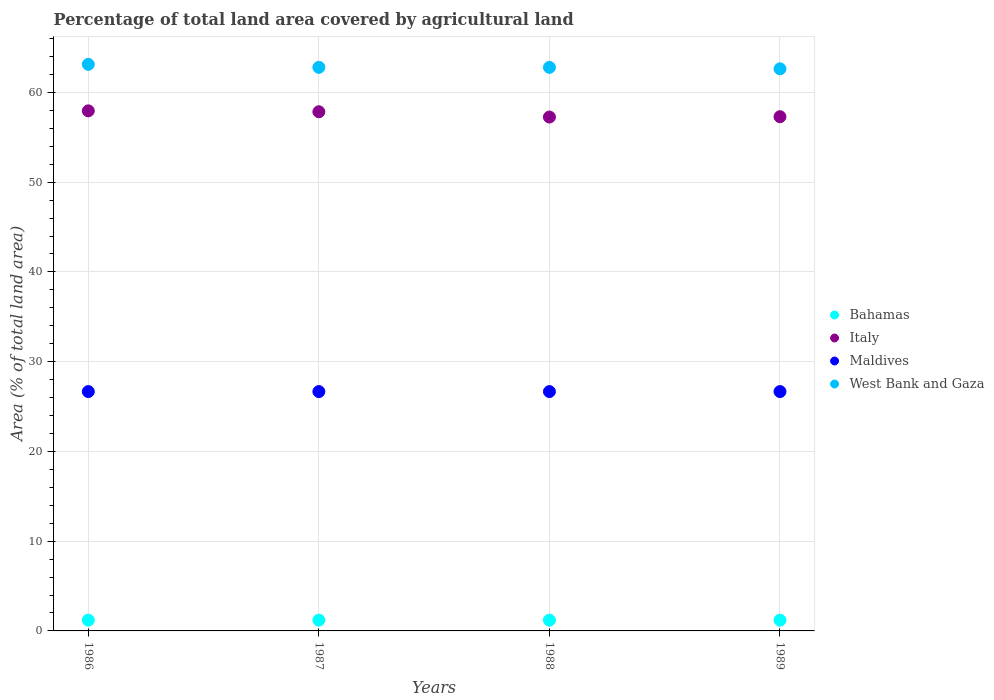How many different coloured dotlines are there?
Your answer should be compact. 4. What is the percentage of agricultural land in West Bank and Gaza in 1986?
Ensure brevity in your answer.  63.12. Across all years, what is the maximum percentage of agricultural land in Maldives?
Give a very brief answer. 26.67. Across all years, what is the minimum percentage of agricultural land in Italy?
Offer a terse response. 57.25. What is the total percentage of agricultural land in West Bank and Gaza in the graph?
Provide a succinct answer. 251.33. What is the difference between the percentage of agricultural land in West Bank and Gaza in 1987 and that in 1989?
Ensure brevity in your answer.  0.17. What is the difference between the percentage of agricultural land in West Bank and Gaza in 1986 and the percentage of agricultural land in Maldives in 1987?
Ensure brevity in your answer.  36.46. What is the average percentage of agricultural land in Bahamas per year?
Keep it short and to the point. 1.2. In the year 1986, what is the difference between the percentage of agricultural land in Bahamas and percentage of agricultural land in Italy?
Your response must be concise. -56.75. In how many years, is the percentage of agricultural land in West Bank and Gaza greater than 64 %?
Offer a very short reply. 0. What is the ratio of the percentage of agricultural land in Maldives in 1986 to that in 1989?
Keep it short and to the point. 1. Is the difference between the percentage of agricultural land in Bahamas in 1987 and 1988 greater than the difference between the percentage of agricultural land in Italy in 1987 and 1988?
Your answer should be very brief. No. What is the difference between the highest and the second highest percentage of agricultural land in Maldives?
Your answer should be very brief. 0. What is the difference between the highest and the lowest percentage of agricultural land in Bahamas?
Ensure brevity in your answer.  0. In how many years, is the percentage of agricultural land in Maldives greater than the average percentage of agricultural land in Maldives taken over all years?
Your answer should be compact. 0. Is the sum of the percentage of agricultural land in West Bank and Gaza in 1986 and 1988 greater than the maximum percentage of agricultural land in Maldives across all years?
Ensure brevity in your answer.  Yes. Is it the case that in every year, the sum of the percentage of agricultural land in Maldives and percentage of agricultural land in Bahamas  is greater than the percentage of agricultural land in Italy?
Make the answer very short. No. Does the percentage of agricultural land in Italy monotonically increase over the years?
Make the answer very short. No. Is the percentage of agricultural land in West Bank and Gaza strictly less than the percentage of agricultural land in Maldives over the years?
Your response must be concise. No. How many legend labels are there?
Offer a terse response. 4. What is the title of the graph?
Offer a very short reply. Percentage of total land area covered by agricultural land. Does "Turkmenistan" appear as one of the legend labels in the graph?
Provide a short and direct response. No. What is the label or title of the X-axis?
Your answer should be compact. Years. What is the label or title of the Y-axis?
Keep it short and to the point. Area (% of total land area). What is the Area (% of total land area) of Bahamas in 1986?
Your response must be concise. 1.2. What is the Area (% of total land area) in Italy in 1986?
Offer a very short reply. 57.94. What is the Area (% of total land area) in Maldives in 1986?
Make the answer very short. 26.67. What is the Area (% of total land area) of West Bank and Gaza in 1986?
Give a very brief answer. 63.12. What is the Area (% of total land area) in Bahamas in 1987?
Give a very brief answer. 1.2. What is the Area (% of total land area) in Italy in 1987?
Provide a succinct answer. 57.84. What is the Area (% of total land area) of Maldives in 1987?
Give a very brief answer. 26.67. What is the Area (% of total land area) of West Bank and Gaza in 1987?
Offer a very short reply. 62.79. What is the Area (% of total land area) of Bahamas in 1988?
Your answer should be very brief. 1.2. What is the Area (% of total land area) in Italy in 1988?
Offer a very short reply. 57.25. What is the Area (% of total land area) in Maldives in 1988?
Offer a very short reply. 26.67. What is the Area (% of total land area) of West Bank and Gaza in 1988?
Your response must be concise. 62.79. What is the Area (% of total land area) in Bahamas in 1989?
Offer a very short reply. 1.2. What is the Area (% of total land area) of Italy in 1989?
Give a very brief answer. 57.29. What is the Area (% of total land area) of Maldives in 1989?
Make the answer very short. 26.67. What is the Area (% of total land area) of West Bank and Gaza in 1989?
Your answer should be compact. 62.62. Across all years, what is the maximum Area (% of total land area) in Bahamas?
Offer a very short reply. 1.2. Across all years, what is the maximum Area (% of total land area) of Italy?
Your answer should be compact. 57.94. Across all years, what is the maximum Area (% of total land area) of Maldives?
Provide a succinct answer. 26.67. Across all years, what is the maximum Area (% of total land area) in West Bank and Gaza?
Your response must be concise. 63.12. Across all years, what is the minimum Area (% of total land area) of Bahamas?
Offer a terse response. 1.2. Across all years, what is the minimum Area (% of total land area) of Italy?
Your response must be concise. 57.25. Across all years, what is the minimum Area (% of total land area) of Maldives?
Your response must be concise. 26.67. Across all years, what is the minimum Area (% of total land area) in West Bank and Gaza?
Keep it short and to the point. 62.62. What is the total Area (% of total land area) of Bahamas in the graph?
Ensure brevity in your answer.  4.8. What is the total Area (% of total land area) in Italy in the graph?
Your response must be concise. 230.33. What is the total Area (% of total land area) in Maldives in the graph?
Provide a short and direct response. 106.67. What is the total Area (% of total land area) of West Bank and Gaza in the graph?
Your response must be concise. 251.33. What is the difference between the Area (% of total land area) of Italy in 1986 and that in 1987?
Give a very brief answer. 0.1. What is the difference between the Area (% of total land area) in Maldives in 1986 and that in 1987?
Your answer should be compact. 0. What is the difference between the Area (% of total land area) of West Bank and Gaza in 1986 and that in 1987?
Your response must be concise. 0.33. What is the difference between the Area (% of total land area) in Bahamas in 1986 and that in 1988?
Ensure brevity in your answer.  0. What is the difference between the Area (% of total land area) of Italy in 1986 and that in 1988?
Give a very brief answer. 0.69. What is the difference between the Area (% of total land area) of West Bank and Gaza in 1986 and that in 1988?
Your answer should be compact. 0.33. What is the difference between the Area (% of total land area) of Bahamas in 1986 and that in 1989?
Your response must be concise. 0. What is the difference between the Area (% of total land area) in Italy in 1986 and that in 1989?
Provide a succinct answer. 0.65. What is the difference between the Area (% of total land area) in Maldives in 1986 and that in 1989?
Your answer should be compact. 0. What is the difference between the Area (% of total land area) of West Bank and Gaza in 1986 and that in 1989?
Ensure brevity in your answer.  0.5. What is the difference between the Area (% of total land area) of Italy in 1987 and that in 1988?
Keep it short and to the point. 0.59. What is the difference between the Area (% of total land area) of Italy in 1987 and that in 1989?
Your answer should be compact. 0.55. What is the difference between the Area (% of total land area) of Maldives in 1987 and that in 1989?
Your answer should be compact. 0. What is the difference between the Area (% of total land area) of West Bank and Gaza in 1987 and that in 1989?
Your answer should be compact. 0.17. What is the difference between the Area (% of total land area) in Italy in 1988 and that in 1989?
Your answer should be very brief. -0.04. What is the difference between the Area (% of total land area) of Maldives in 1988 and that in 1989?
Provide a succinct answer. 0. What is the difference between the Area (% of total land area) in West Bank and Gaza in 1988 and that in 1989?
Offer a terse response. 0.17. What is the difference between the Area (% of total land area) of Bahamas in 1986 and the Area (% of total land area) of Italy in 1987?
Offer a terse response. -56.64. What is the difference between the Area (% of total land area) in Bahamas in 1986 and the Area (% of total land area) in Maldives in 1987?
Your response must be concise. -25.47. What is the difference between the Area (% of total land area) in Bahamas in 1986 and the Area (% of total land area) in West Bank and Gaza in 1987?
Your response must be concise. -61.59. What is the difference between the Area (% of total land area) of Italy in 1986 and the Area (% of total land area) of Maldives in 1987?
Ensure brevity in your answer.  31.28. What is the difference between the Area (% of total land area) of Italy in 1986 and the Area (% of total land area) of West Bank and Gaza in 1987?
Your response must be concise. -4.85. What is the difference between the Area (% of total land area) of Maldives in 1986 and the Area (% of total land area) of West Bank and Gaza in 1987?
Your answer should be very brief. -36.12. What is the difference between the Area (% of total land area) of Bahamas in 1986 and the Area (% of total land area) of Italy in 1988?
Provide a succinct answer. -56.06. What is the difference between the Area (% of total land area) in Bahamas in 1986 and the Area (% of total land area) in Maldives in 1988?
Your answer should be very brief. -25.47. What is the difference between the Area (% of total land area) in Bahamas in 1986 and the Area (% of total land area) in West Bank and Gaza in 1988?
Offer a very short reply. -61.59. What is the difference between the Area (% of total land area) of Italy in 1986 and the Area (% of total land area) of Maldives in 1988?
Give a very brief answer. 31.28. What is the difference between the Area (% of total land area) of Italy in 1986 and the Area (% of total land area) of West Bank and Gaza in 1988?
Offer a very short reply. -4.85. What is the difference between the Area (% of total land area) of Maldives in 1986 and the Area (% of total land area) of West Bank and Gaza in 1988?
Your response must be concise. -36.12. What is the difference between the Area (% of total land area) in Bahamas in 1986 and the Area (% of total land area) in Italy in 1989?
Provide a short and direct response. -56.09. What is the difference between the Area (% of total land area) in Bahamas in 1986 and the Area (% of total land area) in Maldives in 1989?
Give a very brief answer. -25.47. What is the difference between the Area (% of total land area) in Bahamas in 1986 and the Area (% of total land area) in West Bank and Gaza in 1989?
Your answer should be compact. -61.43. What is the difference between the Area (% of total land area) of Italy in 1986 and the Area (% of total land area) of Maldives in 1989?
Offer a very short reply. 31.28. What is the difference between the Area (% of total land area) of Italy in 1986 and the Area (% of total land area) of West Bank and Gaza in 1989?
Ensure brevity in your answer.  -4.68. What is the difference between the Area (% of total land area) of Maldives in 1986 and the Area (% of total land area) of West Bank and Gaza in 1989?
Keep it short and to the point. -35.96. What is the difference between the Area (% of total land area) of Bahamas in 1987 and the Area (% of total land area) of Italy in 1988?
Your answer should be very brief. -56.06. What is the difference between the Area (% of total land area) in Bahamas in 1987 and the Area (% of total land area) in Maldives in 1988?
Provide a short and direct response. -25.47. What is the difference between the Area (% of total land area) of Bahamas in 1987 and the Area (% of total land area) of West Bank and Gaza in 1988?
Make the answer very short. -61.59. What is the difference between the Area (% of total land area) in Italy in 1987 and the Area (% of total land area) in Maldives in 1988?
Ensure brevity in your answer.  31.18. What is the difference between the Area (% of total land area) of Italy in 1987 and the Area (% of total land area) of West Bank and Gaza in 1988?
Ensure brevity in your answer.  -4.95. What is the difference between the Area (% of total land area) of Maldives in 1987 and the Area (% of total land area) of West Bank and Gaza in 1988?
Make the answer very short. -36.12. What is the difference between the Area (% of total land area) in Bahamas in 1987 and the Area (% of total land area) in Italy in 1989?
Keep it short and to the point. -56.09. What is the difference between the Area (% of total land area) in Bahamas in 1987 and the Area (% of total land area) in Maldives in 1989?
Keep it short and to the point. -25.47. What is the difference between the Area (% of total land area) of Bahamas in 1987 and the Area (% of total land area) of West Bank and Gaza in 1989?
Make the answer very short. -61.43. What is the difference between the Area (% of total land area) of Italy in 1987 and the Area (% of total land area) of Maldives in 1989?
Offer a very short reply. 31.18. What is the difference between the Area (% of total land area) of Italy in 1987 and the Area (% of total land area) of West Bank and Gaza in 1989?
Provide a succinct answer. -4.78. What is the difference between the Area (% of total land area) in Maldives in 1987 and the Area (% of total land area) in West Bank and Gaza in 1989?
Your response must be concise. -35.96. What is the difference between the Area (% of total land area) in Bahamas in 1988 and the Area (% of total land area) in Italy in 1989?
Offer a terse response. -56.09. What is the difference between the Area (% of total land area) in Bahamas in 1988 and the Area (% of total land area) in Maldives in 1989?
Your answer should be very brief. -25.47. What is the difference between the Area (% of total land area) of Bahamas in 1988 and the Area (% of total land area) of West Bank and Gaza in 1989?
Make the answer very short. -61.43. What is the difference between the Area (% of total land area) in Italy in 1988 and the Area (% of total land area) in Maldives in 1989?
Provide a short and direct response. 30.59. What is the difference between the Area (% of total land area) in Italy in 1988 and the Area (% of total land area) in West Bank and Gaza in 1989?
Give a very brief answer. -5.37. What is the difference between the Area (% of total land area) of Maldives in 1988 and the Area (% of total land area) of West Bank and Gaza in 1989?
Make the answer very short. -35.96. What is the average Area (% of total land area) in Bahamas per year?
Keep it short and to the point. 1.2. What is the average Area (% of total land area) in Italy per year?
Your answer should be compact. 57.58. What is the average Area (% of total land area) in Maldives per year?
Your response must be concise. 26.67. What is the average Area (% of total land area) of West Bank and Gaza per year?
Your answer should be compact. 62.83. In the year 1986, what is the difference between the Area (% of total land area) of Bahamas and Area (% of total land area) of Italy?
Keep it short and to the point. -56.75. In the year 1986, what is the difference between the Area (% of total land area) in Bahamas and Area (% of total land area) in Maldives?
Provide a succinct answer. -25.47. In the year 1986, what is the difference between the Area (% of total land area) in Bahamas and Area (% of total land area) in West Bank and Gaza?
Offer a very short reply. -61.92. In the year 1986, what is the difference between the Area (% of total land area) of Italy and Area (% of total land area) of Maldives?
Your answer should be compact. 31.28. In the year 1986, what is the difference between the Area (% of total land area) of Italy and Area (% of total land area) of West Bank and Gaza?
Offer a terse response. -5.18. In the year 1986, what is the difference between the Area (% of total land area) in Maldives and Area (% of total land area) in West Bank and Gaza?
Ensure brevity in your answer.  -36.46. In the year 1987, what is the difference between the Area (% of total land area) in Bahamas and Area (% of total land area) in Italy?
Ensure brevity in your answer.  -56.64. In the year 1987, what is the difference between the Area (% of total land area) in Bahamas and Area (% of total land area) in Maldives?
Provide a short and direct response. -25.47. In the year 1987, what is the difference between the Area (% of total land area) of Bahamas and Area (% of total land area) of West Bank and Gaza?
Keep it short and to the point. -61.59. In the year 1987, what is the difference between the Area (% of total land area) of Italy and Area (% of total land area) of Maldives?
Offer a very short reply. 31.18. In the year 1987, what is the difference between the Area (% of total land area) of Italy and Area (% of total land area) of West Bank and Gaza?
Provide a succinct answer. -4.95. In the year 1987, what is the difference between the Area (% of total land area) of Maldives and Area (% of total land area) of West Bank and Gaza?
Your answer should be very brief. -36.12. In the year 1988, what is the difference between the Area (% of total land area) in Bahamas and Area (% of total land area) in Italy?
Offer a very short reply. -56.06. In the year 1988, what is the difference between the Area (% of total land area) in Bahamas and Area (% of total land area) in Maldives?
Offer a terse response. -25.47. In the year 1988, what is the difference between the Area (% of total land area) of Bahamas and Area (% of total land area) of West Bank and Gaza?
Your response must be concise. -61.59. In the year 1988, what is the difference between the Area (% of total land area) of Italy and Area (% of total land area) of Maldives?
Give a very brief answer. 30.59. In the year 1988, what is the difference between the Area (% of total land area) in Italy and Area (% of total land area) in West Bank and Gaza?
Offer a terse response. -5.54. In the year 1988, what is the difference between the Area (% of total land area) in Maldives and Area (% of total land area) in West Bank and Gaza?
Your answer should be very brief. -36.12. In the year 1989, what is the difference between the Area (% of total land area) in Bahamas and Area (% of total land area) in Italy?
Offer a very short reply. -56.09. In the year 1989, what is the difference between the Area (% of total land area) of Bahamas and Area (% of total land area) of Maldives?
Provide a short and direct response. -25.47. In the year 1989, what is the difference between the Area (% of total land area) in Bahamas and Area (% of total land area) in West Bank and Gaza?
Ensure brevity in your answer.  -61.43. In the year 1989, what is the difference between the Area (% of total land area) in Italy and Area (% of total land area) in Maldives?
Your answer should be very brief. 30.62. In the year 1989, what is the difference between the Area (% of total land area) in Italy and Area (% of total land area) in West Bank and Gaza?
Provide a short and direct response. -5.33. In the year 1989, what is the difference between the Area (% of total land area) of Maldives and Area (% of total land area) of West Bank and Gaza?
Provide a short and direct response. -35.96. What is the ratio of the Area (% of total land area) of Bahamas in 1986 to that in 1987?
Ensure brevity in your answer.  1. What is the ratio of the Area (% of total land area) of Italy in 1986 to that in 1987?
Provide a short and direct response. 1. What is the ratio of the Area (% of total land area) in Maldives in 1986 to that in 1987?
Make the answer very short. 1. What is the ratio of the Area (% of total land area) in West Bank and Gaza in 1986 to that in 1987?
Your response must be concise. 1.01. What is the ratio of the Area (% of total land area) of Bahamas in 1986 to that in 1988?
Keep it short and to the point. 1. What is the ratio of the Area (% of total land area) of Italy in 1986 to that in 1988?
Your answer should be compact. 1.01. What is the ratio of the Area (% of total land area) of Bahamas in 1986 to that in 1989?
Give a very brief answer. 1. What is the ratio of the Area (% of total land area) of Italy in 1986 to that in 1989?
Ensure brevity in your answer.  1.01. What is the ratio of the Area (% of total land area) of Maldives in 1986 to that in 1989?
Ensure brevity in your answer.  1. What is the ratio of the Area (% of total land area) of West Bank and Gaza in 1986 to that in 1989?
Ensure brevity in your answer.  1.01. What is the ratio of the Area (% of total land area) in Italy in 1987 to that in 1988?
Give a very brief answer. 1.01. What is the ratio of the Area (% of total land area) in Bahamas in 1987 to that in 1989?
Offer a very short reply. 1. What is the ratio of the Area (% of total land area) in Italy in 1987 to that in 1989?
Offer a terse response. 1.01. What is the ratio of the Area (% of total land area) in West Bank and Gaza in 1987 to that in 1989?
Your response must be concise. 1. What is the ratio of the Area (% of total land area) of Italy in 1988 to that in 1989?
Keep it short and to the point. 1. What is the ratio of the Area (% of total land area) of Maldives in 1988 to that in 1989?
Provide a succinct answer. 1. What is the difference between the highest and the second highest Area (% of total land area) of Italy?
Offer a terse response. 0.1. What is the difference between the highest and the second highest Area (% of total land area) in Maldives?
Provide a short and direct response. 0. What is the difference between the highest and the second highest Area (% of total land area) of West Bank and Gaza?
Ensure brevity in your answer.  0.33. What is the difference between the highest and the lowest Area (% of total land area) of Italy?
Your answer should be very brief. 0.69. What is the difference between the highest and the lowest Area (% of total land area) in West Bank and Gaza?
Your response must be concise. 0.5. 